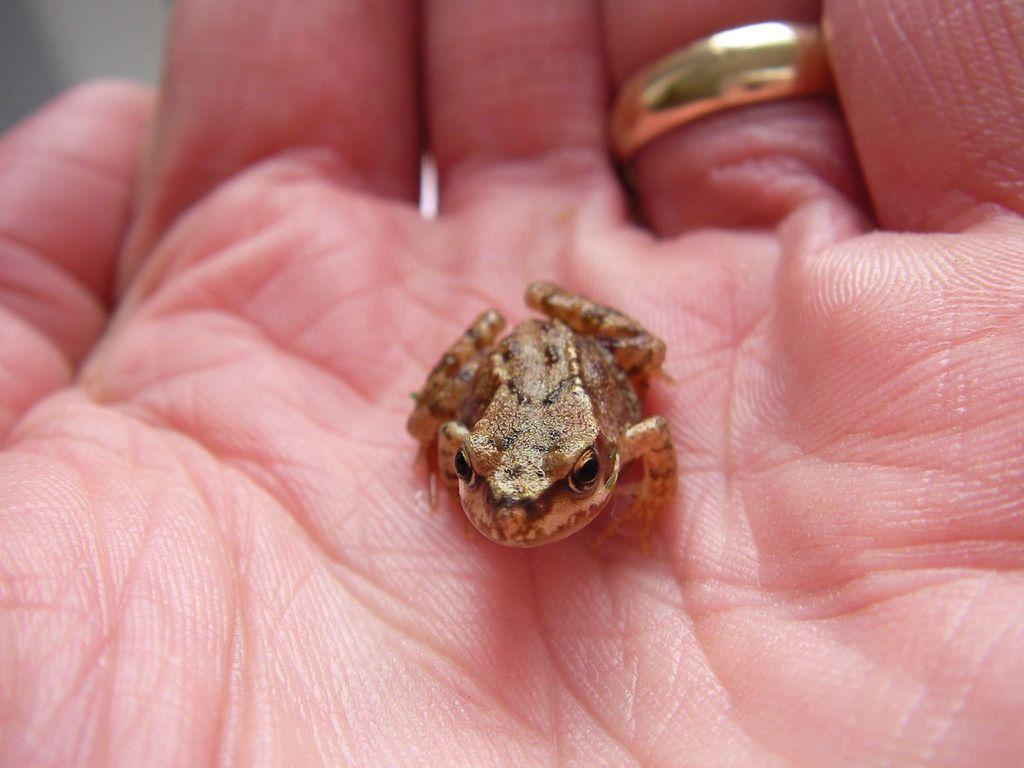What part of a person is visible in the image? There is a palm of a person in the image. Is there any jewelry visible on the person's hand? Yes, there is a ring on one of the fingers in the image. What else can be seen on the palm in the image? There is a frog on the palm in the image. How does the person in the image blow the frog off their palm? There is no indication in the image that the person is blowing the frog off their palm, nor is there any mention of blowing in the provided facts. 